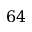Convert formula to latex. <formula><loc_0><loc_0><loc_500><loc_500>6 4</formula> 